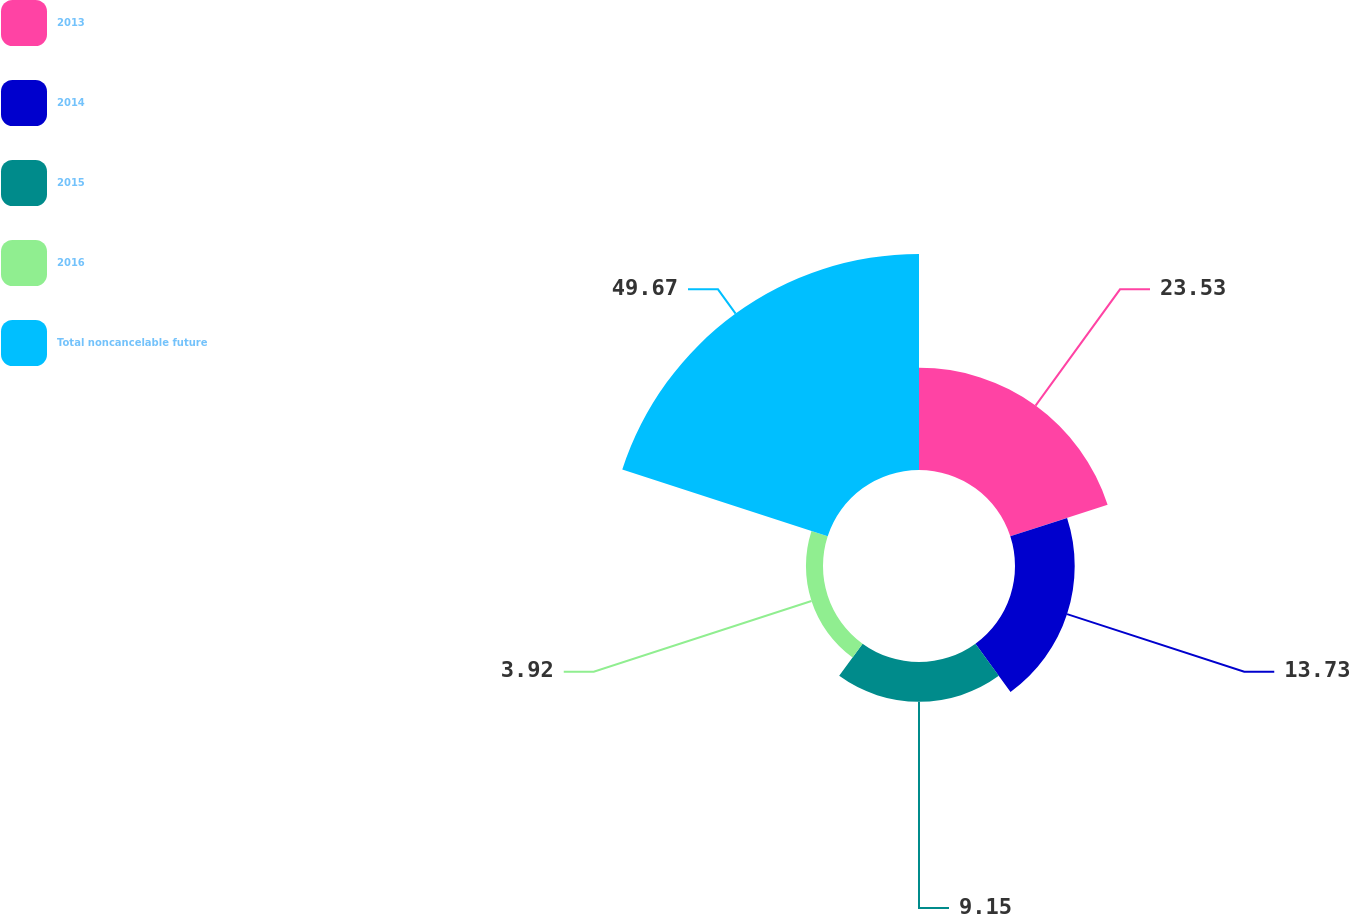Convert chart. <chart><loc_0><loc_0><loc_500><loc_500><pie_chart><fcel>2013<fcel>2014<fcel>2015<fcel>2016<fcel>Total noncancelable future<nl><fcel>23.53%<fcel>13.73%<fcel>9.15%<fcel>3.92%<fcel>49.67%<nl></chart> 